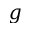<formula> <loc_0><loc_0><loc_500><loc_500>g</formula> 